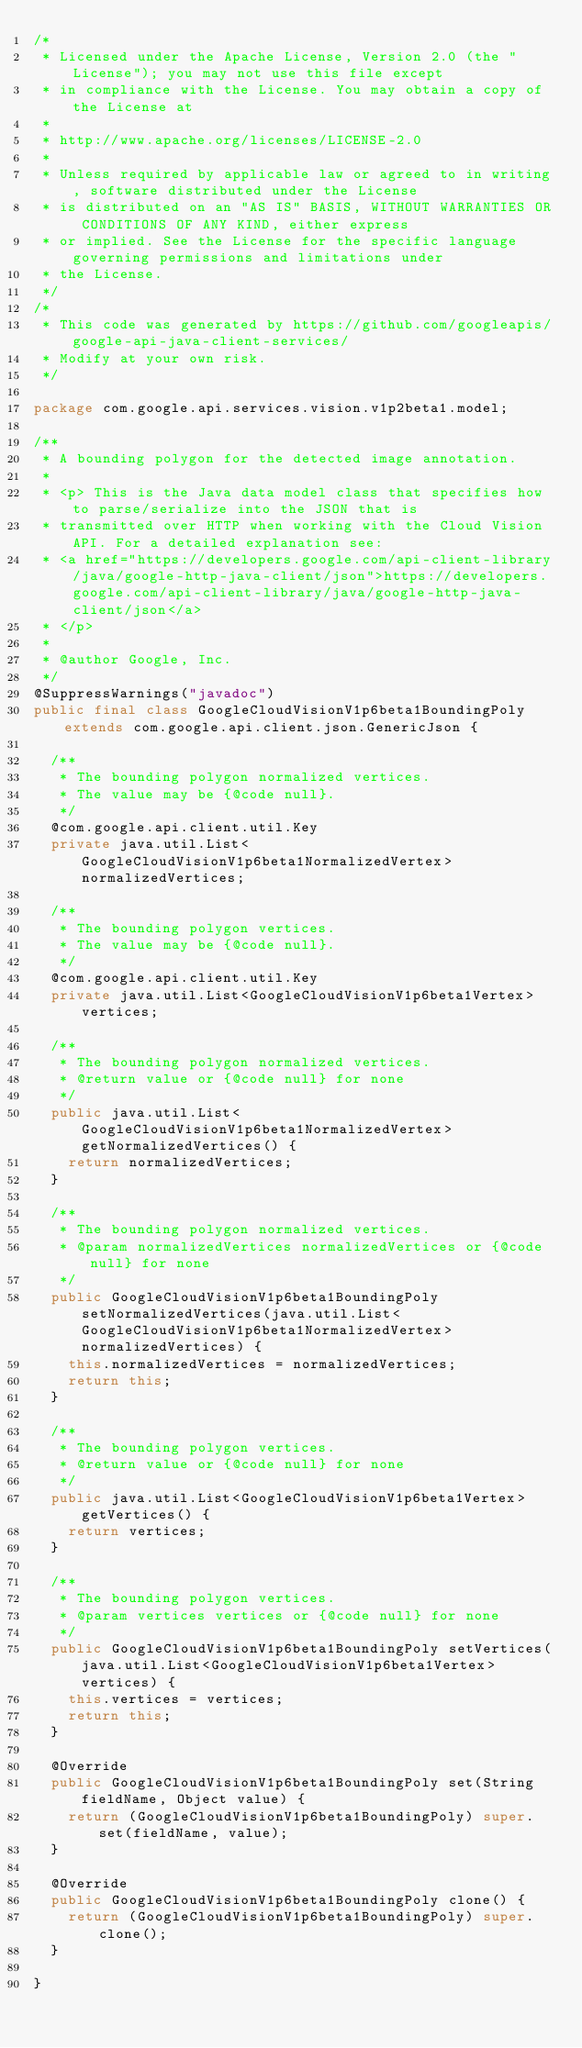Convert code to text. <code><loc_0><loc_0><loc_500><loc_500><_Java_>/*
 * Licensed under the Apache License, Version 2.0 (the "License"); you may not use this file except
 * in compliance with the License. You may obtain a copy of the License at
 *
 * http://www.apache.org/licenses/LICENSE-2.0
 *
 * Unless required by applicable law or agreed to in writing, software distributed under the License
 * is distributed on an "AS IS" BASIS, WITHOUT WARRANTIES OR CONDITIONS OF ANY KIND, either express
 * or implied. See the License for the specific language governing permissions and limitations under
 * the License.
 */
/*
 * This code was generated by https://github.com/googleapis/google-api-java-client-services/
 * Modify at your own risk.
 */

package com.google.api.services.vision.v1p2beta1.model;

/**
 * A bounding polygon for the detected image annotation.
 *
 * <p> This is the Java data model class that specifies how to parse/serialize into the JSON that is
 * transmitted over HTTP when working with the Cloud Vision API. For a detailed explanation see:
 * <a href="https://developers.google.com/api-client-library/java/google-http-java-client/json">https://developers.google.com/api-client-library/java/google-http-java-client/json</a>
 * </p>
 *
 * @author Google, Inc.
 */
@SuppressWarnings("javadoc")
public final class GoogleCloudVisionV1p6beta1BoundingPoly extends com.google.api.client.json.GenericJson {

  /**
   * The bounding polygon normalized vertices.
   * The value may be {@code null}.
   */
  @com.google.api.client.util.Key
  private java.util.List<GoogleCloudVisionV1p6beta1NormalizedVertex> normalizedVertices;

  /**
   * The bounding polygon vertices.
   * The value may be {@code null}.
   */
  @com.google.api.client.util.Key
  private java.util.List<GoogleCloudVisionV1p6beta1Vertex> vertices;

  /**
   * The bounding polygon normalized vertices.
   * @return value or {@code null} for none
   */
  public java.util.List<GoogleCloudVisionV1p6beta1NormalizedVertex> getNormalizedVertices() {
    return normalizedVertices;
  }

  /**
   * The bounding polygon normalized vertices.
   * @param normalizedVertices normalizedVertices or {@code null} for none
   */
  public GoogleCloudVisionV1p6beta1BoundingPoly setNormalizedVertices(java.util.List<GoogleCloudVisionV1p6beta1NormalizedVertex> normalizedVertices) {
    this.normalizedVertices = normalizedVertices;
    return this;
  }

  /**
   * The bounding polygon vertices.
   * @return value or {@code null} for none
   */
  public java.util.List<GoogleCloudVisionV1p6beta1Vertex> getVertices() {
    return vertices;
  }

  /**
   * The bounding polygon vertices.
   * @param vertices vertices or {@code null} for none
   */
  public GoogleCloudVisionV1p6beta1BoundingPoly setVertices(java.util.List<GoogleCloudVisionV1p6beta1Vertex> vertices) {
    this.vertices = vertices;
    return this;
  }

  @Override
  public GoogleCloudVisionV1p6beta1BoundingPoly set(String fieldName, Object value) {
    return (GoogleCloudVisionV1p6beta1BoundingPoly) super.set(fieldName, value);
  }

  @Override
  public GoogleCloudVisionV1p6beta1BoundingPoly clone() {
    return (GoogleCloudVisionV1p6beta1BoundingPoly) super.clone();
  }

}
</code> 